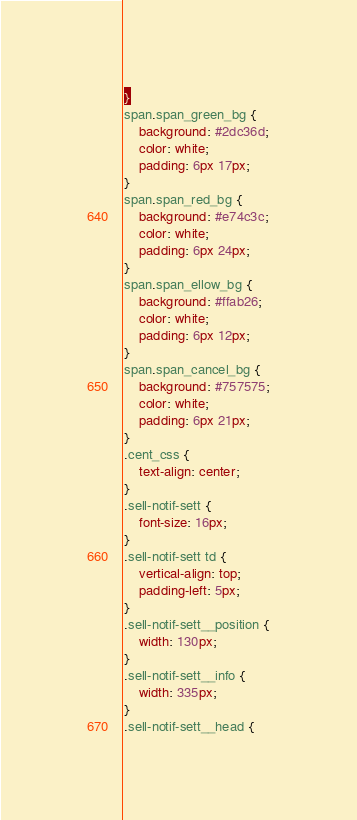<code> <loc_0><loc_0><loc_500><loc_500><_CSS_>}
span.span_green_bg { 
	background: #2dc36d;
	color: white;
	padding: 6px 17px;
}
span.span_red_bg {
	background: #e74c3c;
	color: white;
	padding: 6px 24px;
}
span.span_ellow_bg { 
	background: #ffab26;
	color: white;
	padding: 6px 12px;
}
span.span_cancel_bg {
	background: #757575;
	color: white;
	padding: 6px 21px;
}
.cent_css {
	text-align: center;
}
.sell-notif-sett {
	font-size: 16px;
}
.sell-notif-sett td {
	vertical-align: top;
	padding-left: 5px;
}
.sell-notif-sett__position {
	width: 130px;
}
.sell-notif-sett__info {
	width: 335px;
}
.sell-notif-sett__head {</code> 